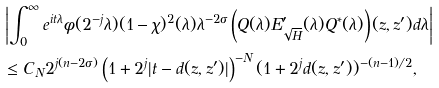<formula> <loc_0><loc_0><loc_500><loc_500>& \left | \int _ { 0 } ^ { \infty } e ^ { i t \lambda } \phi ( 2 ^ { - j } \lambda ) ( 1 - \chi ) ^ { 2 } ( \lambda ) \lambda ^ { - 2 \sigma } \left ( Q ( \lambda ) E ^ { \prime } _ { \sqrt { H } } ( \lambda ) Q ^ { * } ( \lambda ) \right ) ( z , z ^ { \prime } ) d \lambda \right | \\ & \leq C _ { N } 2 ^ { j ( n - 2 \sigma ) } \left ( 1 + 2 ^ { j } | t - d ( z , z ^ { \prime } ) | \right ) ^ { - N } ( 1 + 2 ^ { j } d ( z , z ^ { \prime } ) ) ^ { - ( n - 1 ) / 2 } ,</formula> 